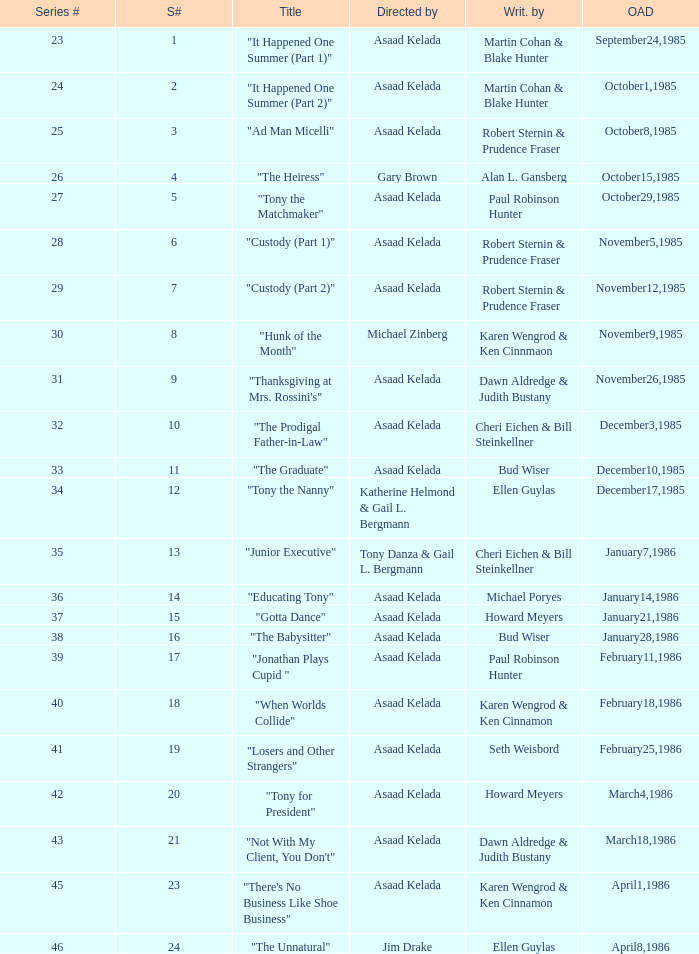What is the season where the episode "when worlds collide" was shown? 18.0. 